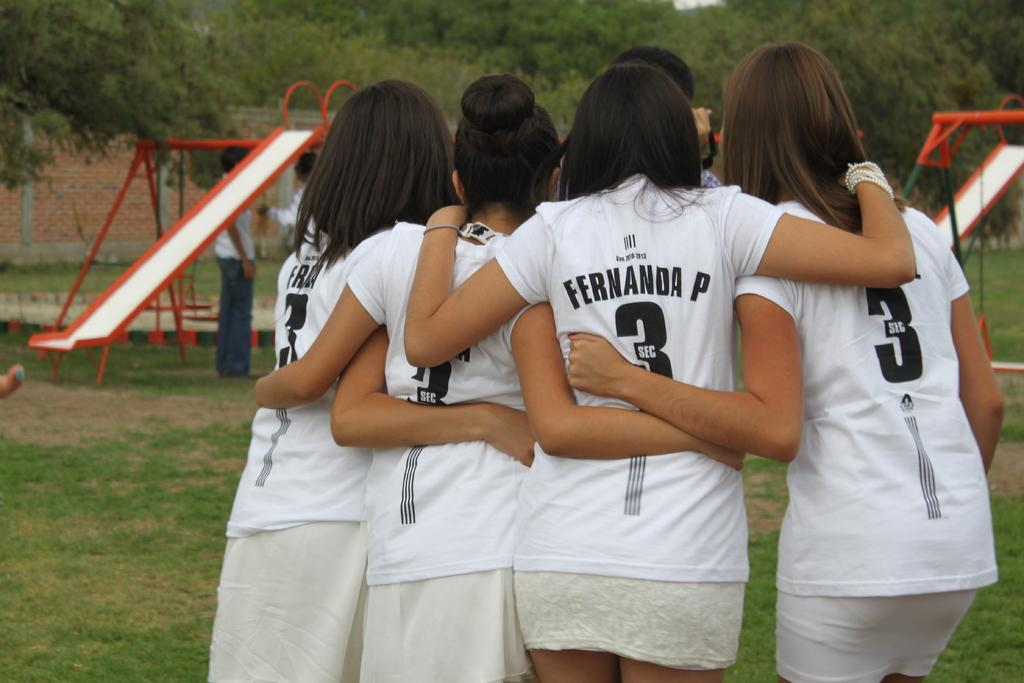<image>
Present a compact description of the photo's key features. A group of girls with their backs facing the camera have the letters SEC on their back 